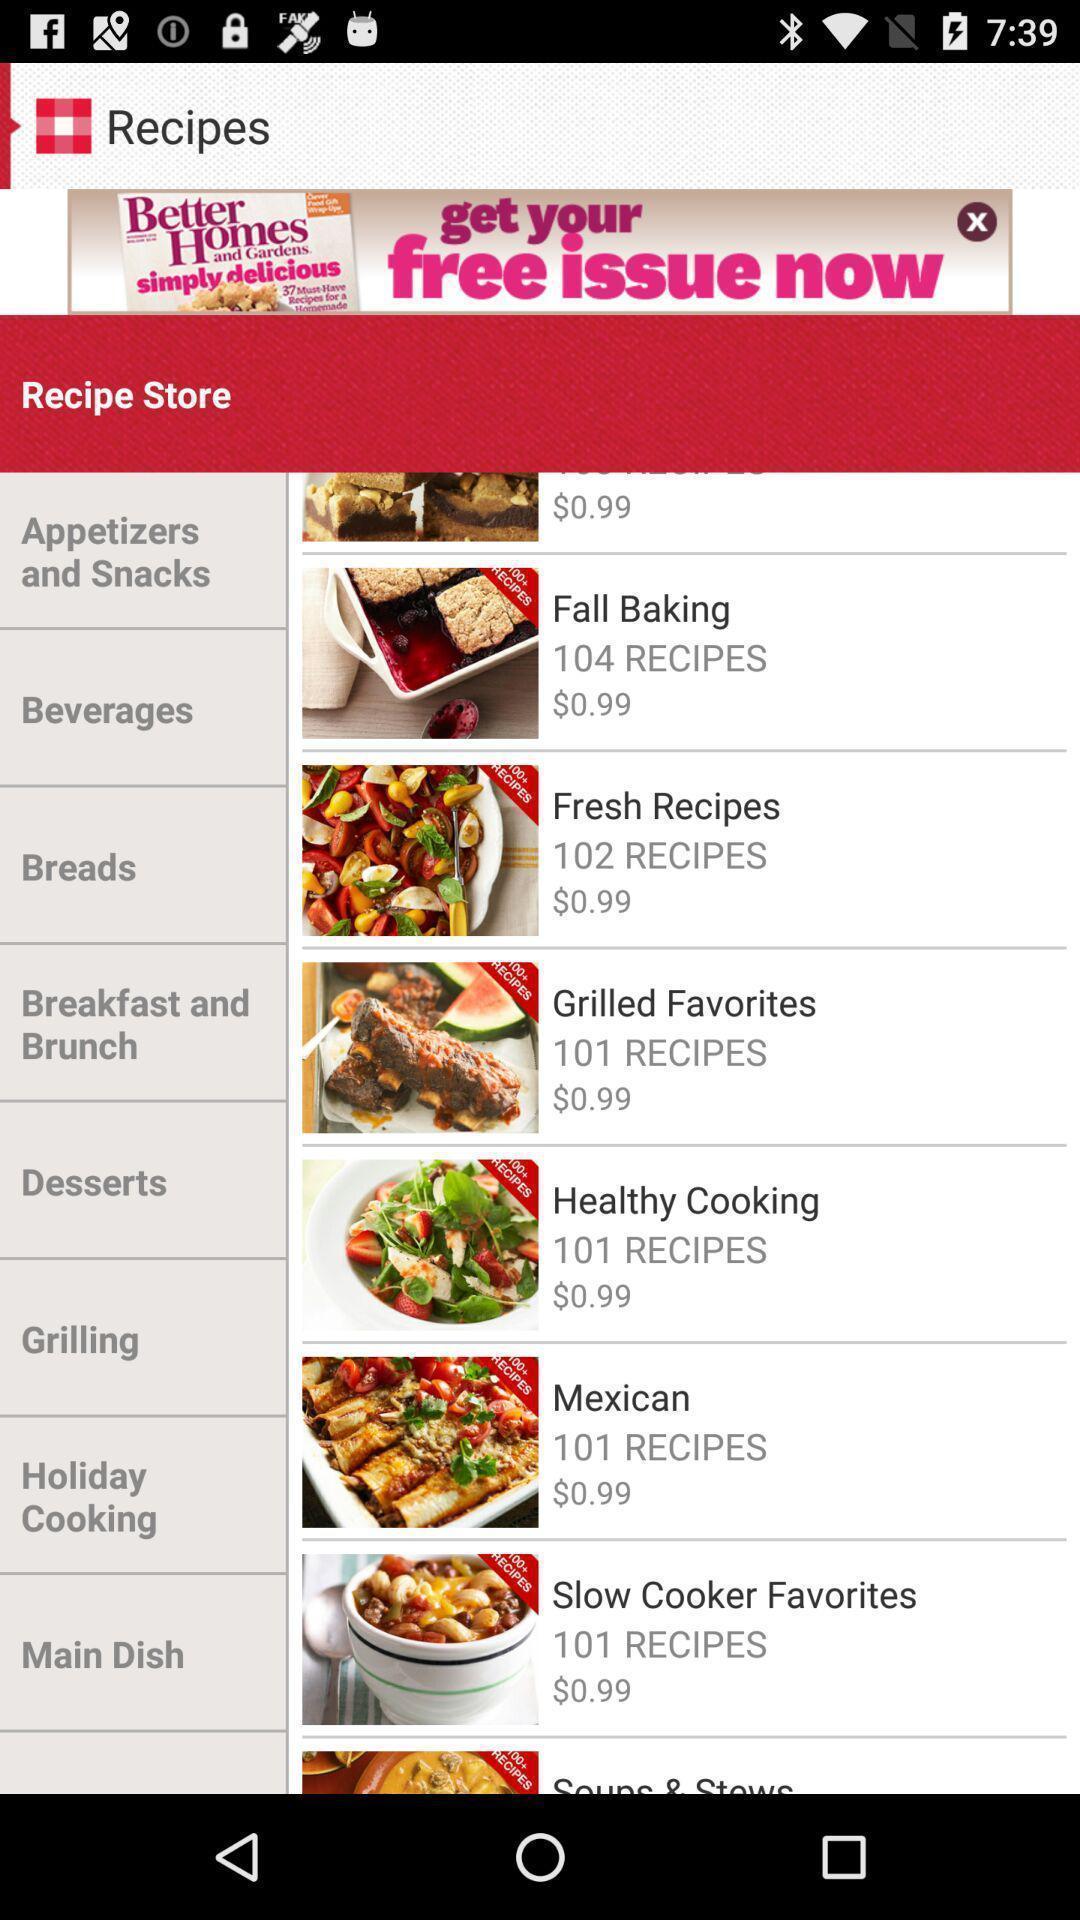Provide a textual representation of this image. Screen displaying list of recipes on recipes app. 